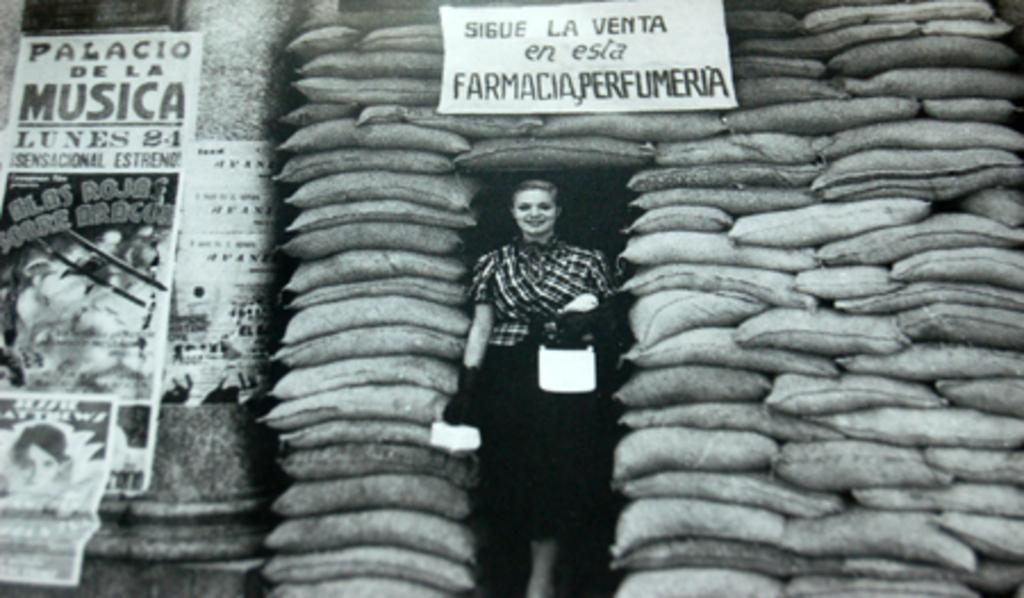Who is present in the image? There is a woman in the image. What is the woman holding in her hand? The woman is holding an object in her hand. Can you describe the board in the image? There is a board in the image. What can be seen on the walls in the image? There are posters in the image. What is the background of the image made of? There is a wall in the image. What is on the floor in the image? There are bags on the floor in the image. Where might this image have been taken? The image may have been taken in a go-down. What type of watch can be seen on the woman's wrist in the image? There is no watch visible on the woman's wrist in the image. What is the woman doing with the ice in the image? There is no ice present in the image, so it is not possible to determine what the woman might be doing with it. 